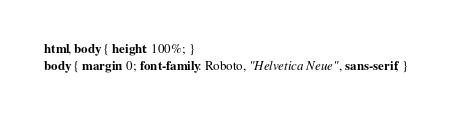<code> <loc_0><loc_0><loc_500><loc_500><_CSS_>


html, body { height: 100%; }
body { margin: 0; font-family: Roboto, "Helvetica Neue", sans-serif; }
</code> 